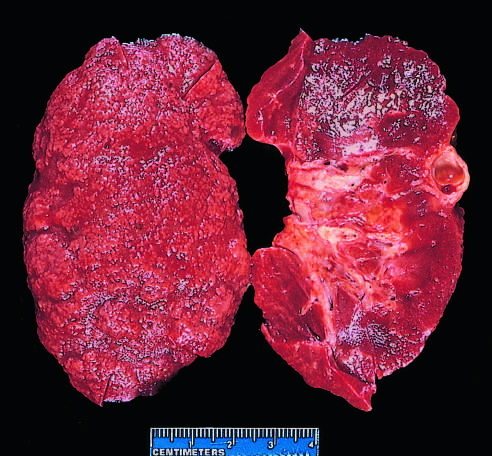do infants who survive include some irregular depressions, the result of pyelonephritis, and an incidental cortical cyst far right?
Answer the question using a single word or phrase. No 